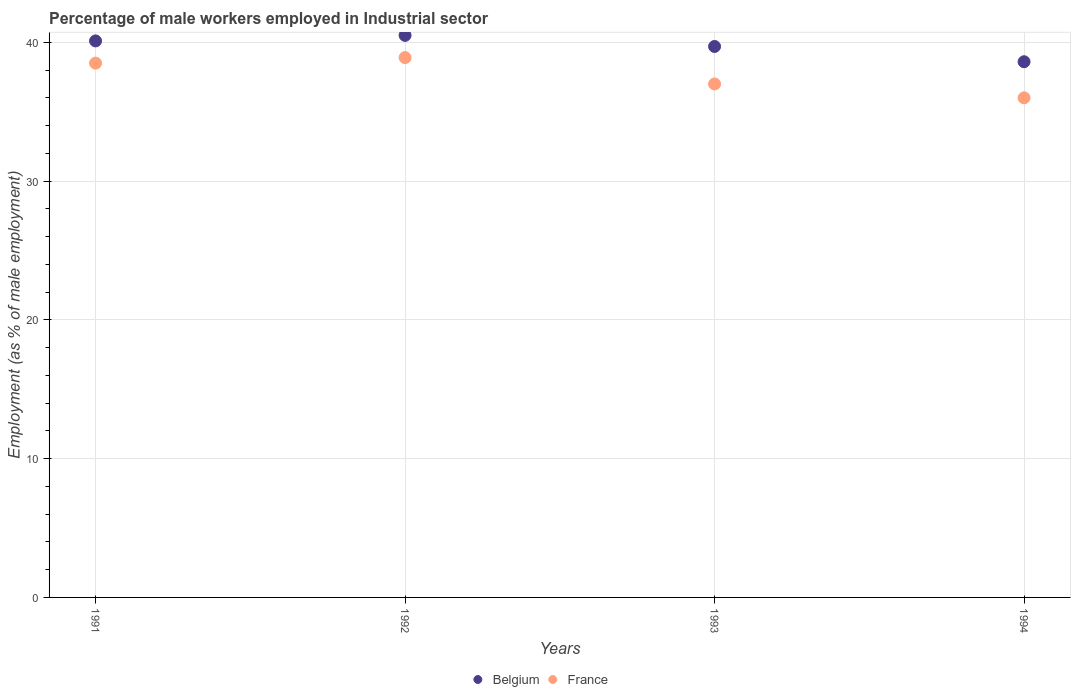Is the number of dotlines equal to the number of legend labels?
Make the answer very short. Yes. What is the percentage of male workers employed in Industrial sector in Belgium in 1993?
Offer a very short reply. 39.7. Across all years, what is the maximum percentage of male workers employed in Industrial sector in Belgium?
Give a very brief answer. 40.5. Across all years, what is the minimum percentage of male workers employed in Industrial sector in Belgium?
Give a very brief answer. 38.6. In which year was the percentage of male workers employed in Industrial sector in Belgium maximum?
Give a very brief answer. 1992. What is the total percentage of male workers employed in Industrial sector in France in the graph?
Offer a terse response. 150.4. What is the difference between the percentage of male workers employed in Industrial sector in France in 1992 and that in 1994?
Ensure brevity in your answer.  2.9. What is the average percentage of male workers employed in Industrial sector in France per year?
Your answer should be very brief. 37.6. In the year 1991, what is the difference between the percentage of male workers employed in Industrial sector in France and percentage of male workers employed in Industrial sector in Belgium?
Provide a short and direct response. -1.6. What is the ratio of the percentage of male workers employed in Industrial sector in France in 1992 to that in 1993?
Offer a terse response. 1.05. Is the difference between the percentage of male workers employed in Industrial sector in France in 1991 and 1993 greater than the difference between the percentage of male workers employed in Industrial sector in Belgium in 1991 and 1993?
Offer a very short reply. Yes. What is the difference between the highest and the second highest percentage of male workers employed in Industrial sector in Belgium?
Keep it short and to the point. 0.4. What is the difference between the highest and the lowest percentage of male workers employed in Industrial sector in France?
Keep it short and to the point. 2.9. Is the sum of the percentage of male workers employed in Industrial sector in France in 1993 and 1994 greater than the maximum percentage of male workers employed in Industrial sector in Belgium across all years?
Offer a very short reply. Yes. Is the percentage of male workers employed in Industrial sector in France strictly greater than the percentage of male workers employed in Industrial sector in Belgium over the years?
Your response must be concise. No. Is the percentage of male workers employed in Industrial sector in France strictly less than the percentage of male workers employed in Industrial sector in Belgium over the years?
Provide a succinct answer. Yes. How many dotlines are there?
Keep it short and to the point. 2. Does the graph contain any zero values?
Give a very brief answer. No. Does the graph contain grids?
Keep it short and to the point. Yes. How are the legend labels stacked?
Provide a short and direct response. Horizontal. What is the title of the graph?
Give a very brief answer. Percentage of male workers employed in Industrial sector. What is the label or title of the X-axis?
Your answer should be compact. Years. What is the label or title of the Y-axis?
Ensure brevity in your answer.  Employment (as % of male employment). What is the Employment (as % of male employment) in Belgium in 1991?
Your response must be concise. 40.1. What is the Employment (as % of male employment) of France in 1991?
Give a very brief answer. 38.5. What is the Employment (as % of male employment) of Belgium in 1992?
Your answer should be compact. 40.5. What is the Employment (as % of male employment) in France in 1992?
Offer a very short reply. 38.9. What is the Employment (as % of male employment) in Belgium in 1993?
Offer a very short reply. 39.7. What is the Employment (as % of male employment) of Belgium in 1994?
Keep it short and to the point. 38.6. Across all years, what is the maximum Employment (as % of male employment) in Belgium?
Your answer should be compact. 40.5. Across all years, what is the maximum Employment (as % of male employment) of France?
Ensure brevity in your answer.  38.9. Across all years, what is the minimum Employment (as % of male employment) in Belgium?
Offer a terse response. 38.6. What is the total Employment (as % of male employment) in Belgium in the graph?
Provide a short and direct response. 158.9. What is the total Employment (as % of male employment) of France in the graph?
Your answer should be compact. 150.4. What is the difference between the Employment (as % of male employment) in France in 1991 and that in 1993?
Your response must be concise. 1.5. What is the difference between the Employment (as % of male employment) of Belgium in 1991 and that in 1994?
Your response must be concise. 1.5. What is the difference between the Employment (as % of male employment) in France in 1991 and that in 1994?
Keep it short and to the point. 2.5. What is the difference between the Employment (as % of male employment) in France in 1993 and that in 1994?
Make the answer very short. 1. What is the difference between the Employment (as % of male employment) of Belgium in 1991 and the Employment (as % of male employment) of France in 1992?
Provide a succinct answer. 1.2. What is the difference between the Employment (as % of male employment) of Belgium in 1991 and the Employment (as % of male employment) of France in 1993?
Provide a short and direct response. 3.1. What is the difference between the Employment (as % of male employment) in Belgium in 1991 and the Employment (as % of male employment) in France in 1994?
Provide a succinct answer. 4.1. What is the difference between the Employment (as % of male employment) in Belgium in 1992 and the Employment (as % of male employment) in France in 1993?
Give a very brief answer. 3.5. What is the difference between the Employment (as % of male employment) in Belgium in 1993 and the Employment (as % of male employment) in France in 1994?
Your answer should be compact. 3.7. What is the average Employment (as % of male employment) in Belgium per year?
Provide a short and direct response. 39.73. What is the average Employment (as % of male employment) in France per year?
Your response must be concise. 37.6. In the year 1991, what is the difference between the Employment (as % of male employment) of Belgium and Employment (as % of male employment) of France?
Provide a succinct answer. 1.6. In the year 1992, what is the difference between the Employment (as % of male employment) of Belgium and Employment (as % of male employment) of France?
Your answer should be compact. 1.6. In the year 1994, what is the difference between the Employment (as % of male employment) in Belgium and Employment (as % of male employment) in France?
Offer a very short reply. 2.6. What is the ratio of the Employment (as % of male employment) in France in 1991 to that in 1993?
Offer a terse response. 1.04. What is the ratio of the Employment (as % of male employment) of Belgium in 1991 to that in 1994?
Offer a very short reply. 1.04. What is the ratio of the Employment (as % of male employment) in France in 1991 to that in 1994?
Your response must be concise. 1.07. What is the ratio of the Employment (as % of male employment) in Belgium in 1992 to that in 1993?
Provide a succinct answer. 1.02. What is the ratio of the Employment (as % of male employment) of France in 1992 to that in 1993?
Your answer should be compact. 1.05. What is the ratio of the Employment (as % of male employment) in Belgium in 1992 to that in 1994?
Keep it short and to the point. 1.05. What is the ratio of the Employment (as % of male employment) of France in 1992 to that in 1994?
Ensure brevity in your answer.  1.08. What is the ratio of the Employment (as % of male employment) in Belgium in 1993 to that in 1994?
Offer a very short reply. 1.03. What is the ratio of the Employment (as % of male employment) in France in 1993 to that in 1994?
Keep it short and to the point. 1.03. What is the difference between the highest and the lowest Employment (as % of male employment) of France?
Provide a short and direct response. 2.9. 